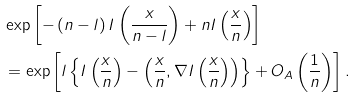Convert formula to latex. <formula><loc_0><loc_0><loc_500><loc_500>& \exp \left [ - \left ( n - l \right ) I \left ( \frac { x } { n - l } \right ) + n I \left ( \frac { x } { n } \right ) \right ] \\ & = \exp \left [ l \left \{ I \left ( \frac { x } { n } \right ) - \left ( \frac { x } { n } , \nabla I \left ( \frac { x } { n } \right ) \right ) \right \} + O _ { A } \left ( \frac { 1 } { n } \right ) \right ] .</formula> 